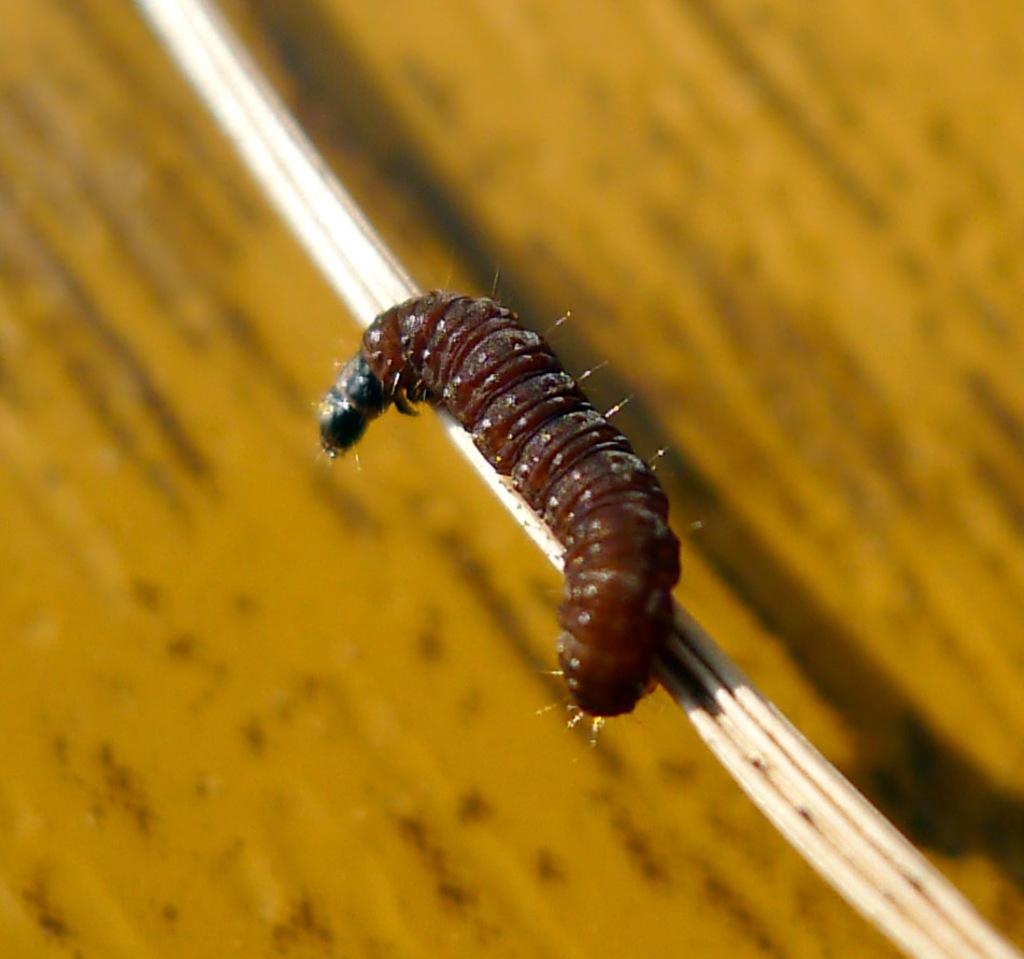What is the main subject of the image? The main subject of the image is a caterpillar. What is the caterpillar doing in the image? The caterpillar is crawling on a wooden stick. Where is the wooden stick located in the image? The wooden stick is on top of a table. What type of representative or achiever can be seen in the image? There is no representative or achiever present in the image; it features a caterpillar crawling on a wooden stick on a table. How many cows are visible in the image? There are no cows present in the image. 